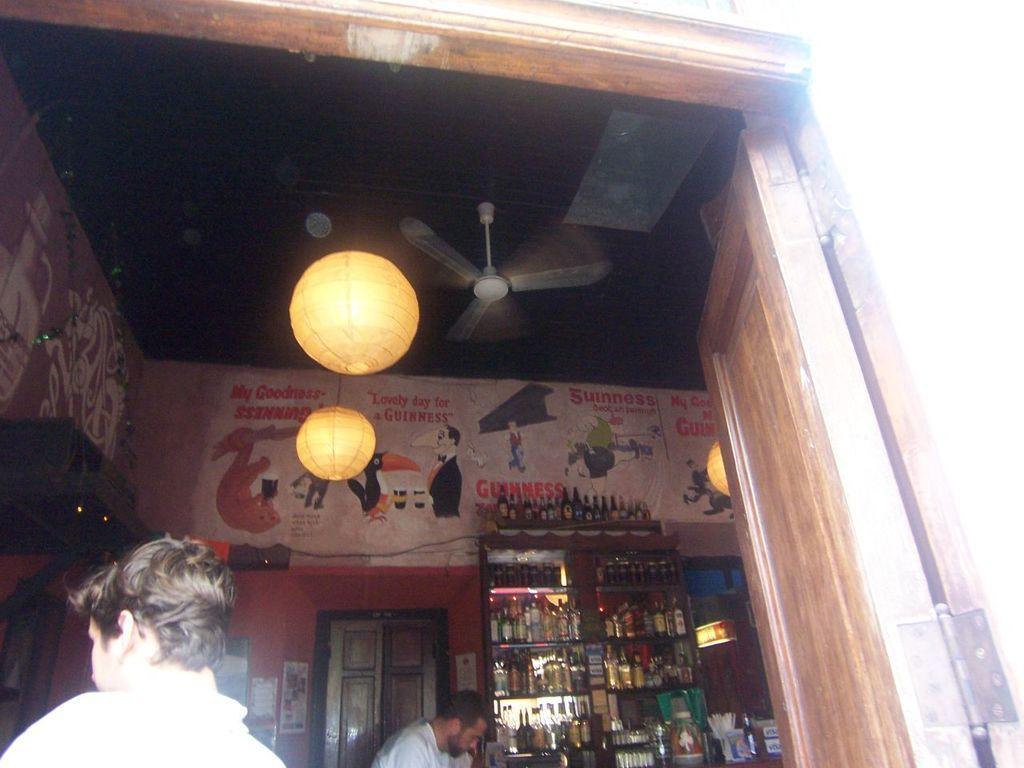How would you summarize this image in a sentence or two? In this image we can see two persons and bottles are arranged in rack. Beside the rack one door is there. Right side of the image one door is present. At the top of the image roof is there and fan is attached to the roof. We can see paintings on the wall. 